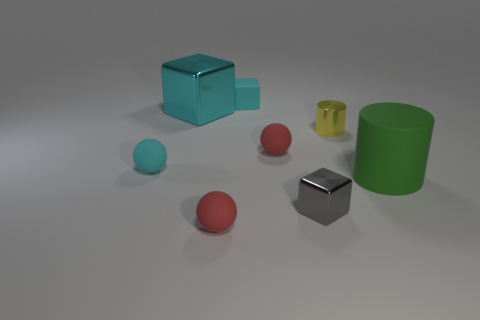What is the color of the thing that is both right of the small gray metal thing and in front of the small cylinder?
Offer a very short reply. Green. There is a small cube that is left of the tiny gray object; what is its material?
Provide a succinct answer. Rubber. Are there any small gray matte things of the same shape as the gray metallic thing?
Ensure brevity in your answer.  No. What number of other things are there of the same shape as the green rubber object?
Give a very brief answer. 1. There is a tiny yellow metal object; is it the same shape as the small metal thing left of the small yellow object?
Your answer should be compact. No. Is there anything else that is made of the same material as the yellow object?
Give a very brief answer. Yes. There is another big thing that is the same shape as the yellow object; what is it made of?
Provide a succinct answer. Rubber. How many tiny things are either gray cylinders or cyan shiny blocks?
Your response must be concise. 0. Is the number of matte cylinders behind the large green object less than the number of green rubber things that are left of the gray metal cube?
Ensure brevity in your answer.  No. What number of things are yellow cylinders or tiny gray matte spheres?
Your answer should be very brief. 1. 